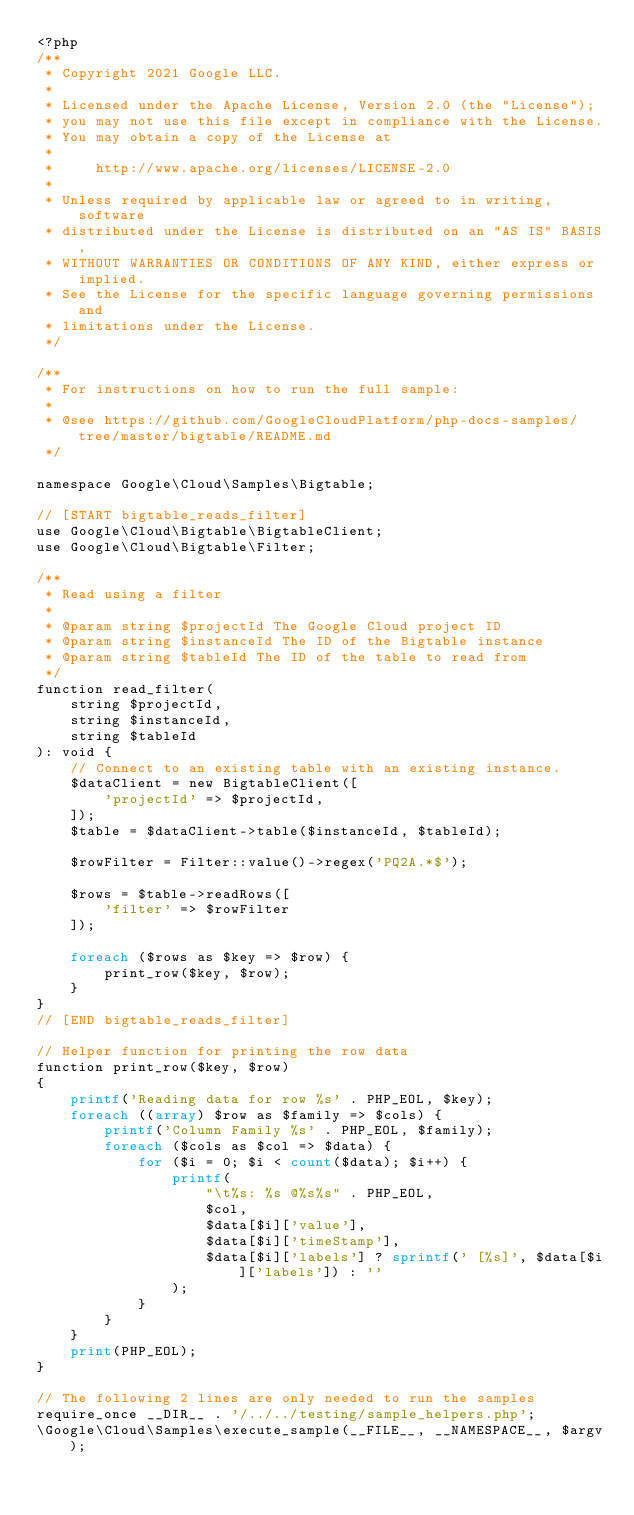<code> <loc_0><loc_0><loc_500><loc_500><_PHP_><?php
/**
 * Copyright 2021 Google LLC.
 *
 * Licensed under the Apache License, Version 2.0 (the "License");
 * you may not use this file except in compliance with the License.
 * You may obtain a copy of the License at
 *
 *     http://www.apache.org/licenses/LICENSE-2.0
 *
 * Unless required by applicable law or agreed to in writing, software
 * distributed under the License is distributed on an "AS IS" BASIS,
 * WITHOUT WARRANTIES OR CONDITIONS OF ANY KIND, either express or implied.
 * See the License for the specific language governing permissions and
 * limitations under the License.
 */

/**
 * For instructions on how to run the full sample:
 *
 * @see https://github.com/GoogleCloudPlatform/php-docs-samples/tree/master/bigtable/README.md
 */

namespace Google\Cloud\Samples\Bigtable;

// [START bigtable_reads_filter]
use Google\Cloud\Bigtable\BigtableClient;
use Google\Cloud\Bigtable\Filter;

/**
 * Read using a filter
 *
 * @param string $projectId The Google Cloud project ID
 * @param string $instanceId The ID of the Bigtable instance
 * @param string $tableId The ID of the table to read from
 */
function read_filter(
    string $projectId,
    string $instanceId,
    string $tableId
): void {
    // Connect to an existing table with an existing instance.
    $dataClient = new BigtableClient([
        'projectId' => $projectId,
    ]);
    $table = $dataClient->table($instanceId, $tableId);

    $rowFilter = Filter::value()->regex('PQ2A.*$');

    $rows = $table->readRows([
        'filter' => $rowFilter
    ]);

    foreach ($rows as $key => $row) {
        print_row($key, $row);
    }
}
// [END bigtable_reads_filter]

// Helper function for printing the row data
function print_row($key, $row)
{
    printf('Reading data for row %s' . PHP_EOL, $key);
    foreach ((array) $row as $family => $cols) {
        printf('Column Family %s' . PHP_EOL, $family);
        foreach ($cols as $col => $data) {
            for ($i = 0; $i < count($data); $i++) {
                printf(
                    "\t%s: %s @%s%s" . PHP_EOL,
                    $col,
                    $data[$i]['value'],
                    $data[$i]['timeStamp'],
                    $data[$i]['labels'] ? sprintf(' [%s]', $data[$i]['labels']) : ''
                );
            }
        }
    }
    print(PHP_EOL);
}

// The following 2 lines are only needed to run the samples
require_once __DIR__ . '/../../testing/sample_helpers.php';
\Google\Cloud\Samples\execute_sample(__FILE__, __NAMESPACE__, $argv);
</code> 